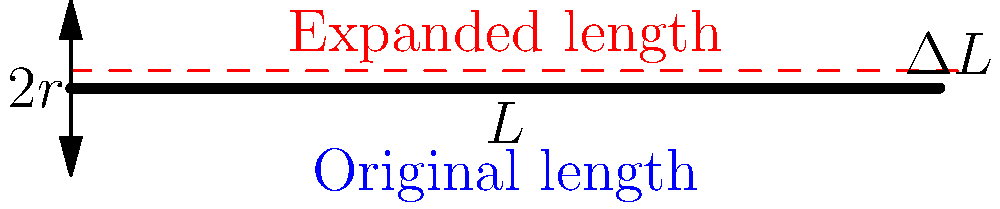A nuclear fuel rod made of uranium dioxide (UO₂) has an initial length of $L = 5$ m and a radius of $r = 0.5$ cm. If the rod experiences a temperature increase of $\Delta T = 500°C$, calculate the thermal stress induced in the rod. Given:
- Coefficient of linear thermal expansion for UO₂, $\alpha = 10 \times 10^{-6}$ /°C
- Young's modulus for UO₂, $E = 200$ GPa
- The rod is constrained and cannot expand freely To solve this problem, we'll follow these steps:

1) First, calculate the thermal strain $\varepsilon_{th}$ that would occur if the rod were free to expand:
   $$\varepsilon_{th} = \alpha \Delta T = (10 \times 10^{-6})(500) = 5 \times 10^{-3}$$

2) Since the rod is constrained and cannot expand, this strain induces a thermal stress. The thermal stress $\sigma_{th}$ is related to the strain by Hooke's law:
   $$\sigma_{th} = E \varepsilon_{th}$$

3) Substitute the values:
   $$\sigma_{th} = (200 \times 10^{9})(5 \times 10^{-3}) = 1 \times 10^{9} \text{ Pa} = 1 \text{ GPa}$$

4) Convert to MPa for a more common unit in engineering:
   $$\sigma_{th} = 1000 \text{ MPa}$$

Therefore, the thermal stress induced in the constrained fuel rod is 1000 MPa or 1 GPa.
Answer: 1000 MPa 